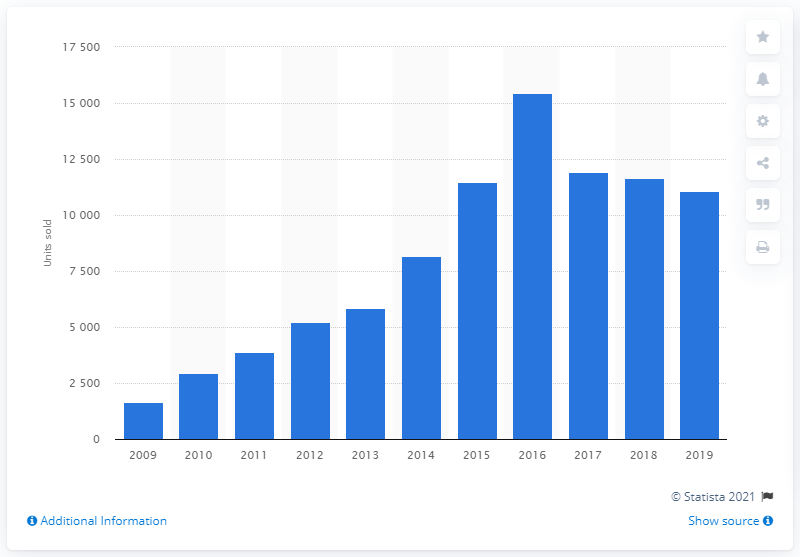Highlight a few significant elements in this photo. In 2019, Hyundai's sales in Ireland totaled 11,052 units. Hyundai achieved its highest sales between 2009 and 2016, with a peak of 15,442 units. In 2017, Hyundai's sales declined. 